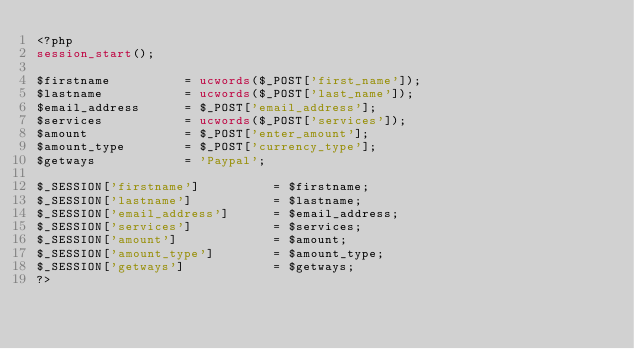Convert code to text. <code><loc_0><loc_0><loc_500><loc_500><_PHP_><?php
session_start();

$firstname          = ucwords($_POST['first_name']);
$lastname           = ucwords($_POST['last_name']);
$email_address      = $_POST['email_address'];
$services           = ucwords($_POST['services']);
$amount             = $_POST['enter_amount'];
$amount_type        = $_POST['currency_type'];
$getways            = 'Paypal';

$_SESSION['firstname']          = $firstname;
$_SESSION['lastname']           = $lastname;
$_SESSION['email_address']      = $email_address;
$_SESSION['services']           = $services;
$_SESSION['amount']             = $amount;
$_SESSION['amount_type']        = $amount_type;
$_SESSION['getways']            = $getways;
?></code> 